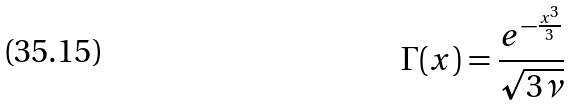Convert formula to latex. <formula><loc_0><loc_0><loc_500><loc_500>\Gamma ( x ) = \frac { e ^ { - \frac { x ^ { 3 } } { 3 } } } { \sqrt { 3 \nu } }</formula> 